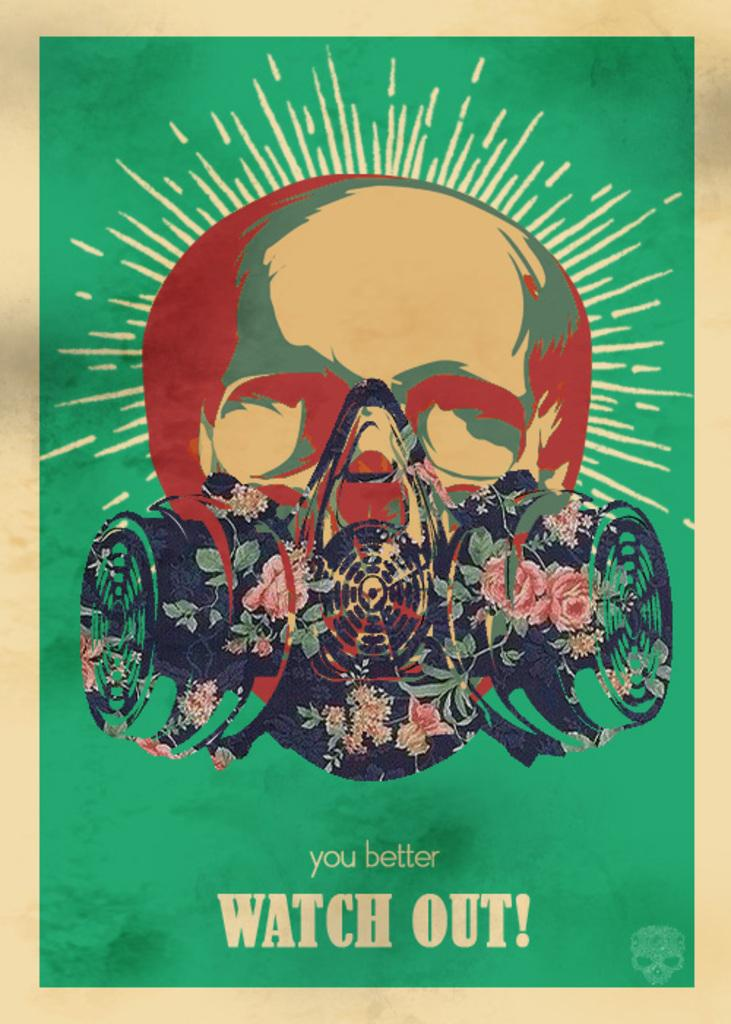What has been done to the image? The image has been edited. What can be seen on the person's face in the image? There is a mask on the person's face in the image. What color is the background of the image? The background of the image is green. What else is present in the image besides the person's face? There is text in the image. How is the image framed? The image has borders. What type of copper faucet can be seen in the image? There is no copper faucet present in the image. How many rooms are visible in the image? There are no rooms visible in the image. 